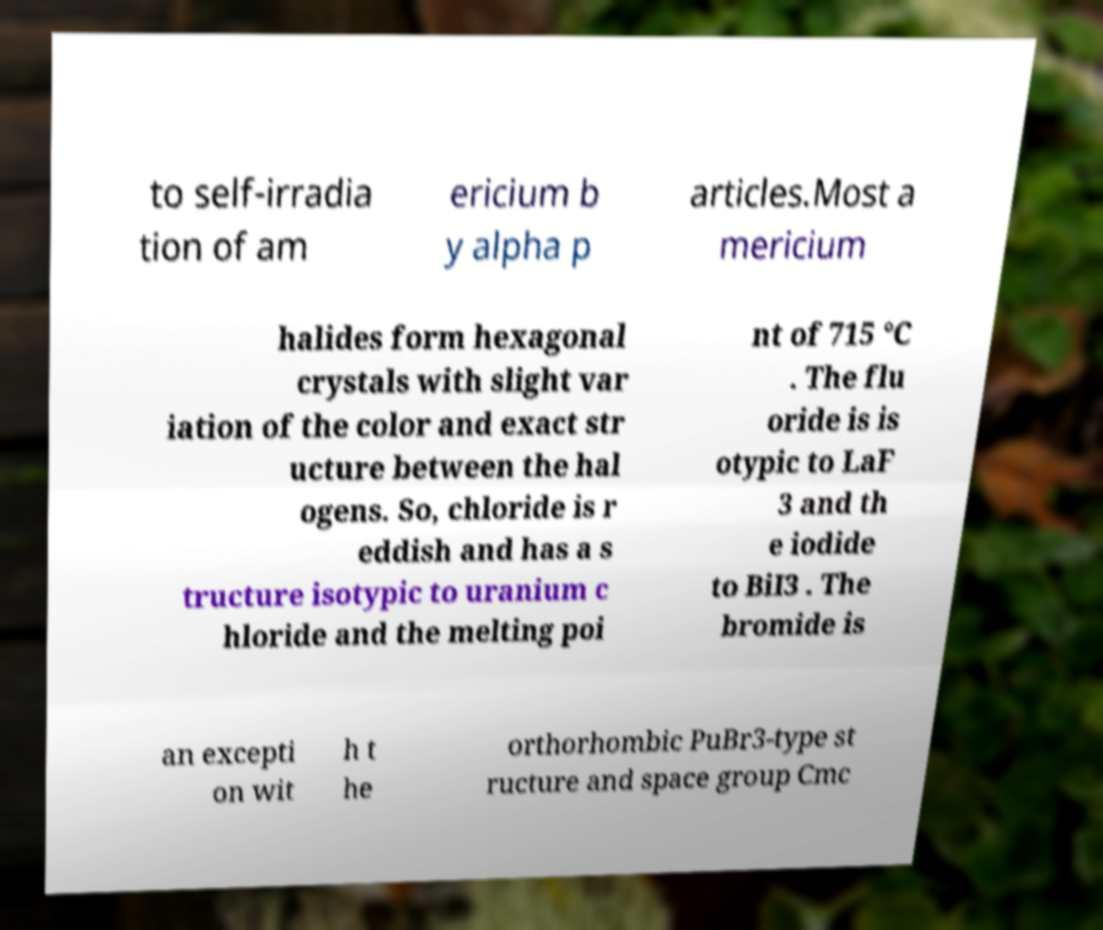Can you accurately transcribe the text from the provided image for me? to self-irradia tion of am ericium b y alpha p articles.Most a mericium halides form hexagonal crystals with slight var iation of the color and exact str ucture between the hal ogens. So, chloride is r eddish and has a s tructure isotypic to uranium c hloride and the melting poi nt of 715 °C . The flu oride is is otypic to LaF 3 and th e iodide to BiI3 . The bromide is an excepti on wit h t he orthorhombic PuBr3-type st ructure and space group Cmc 